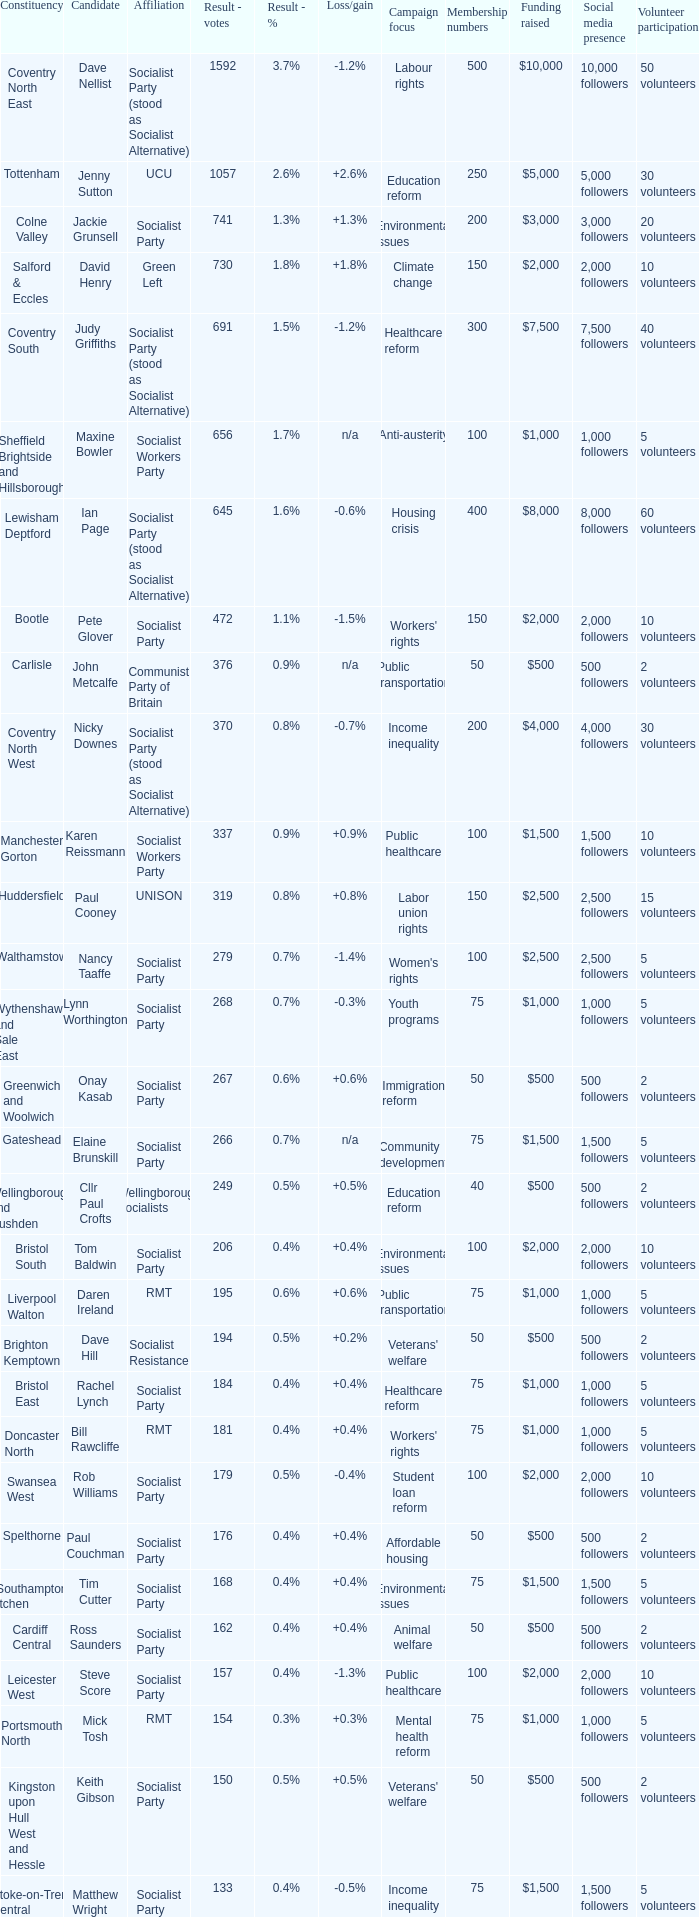What is every candidate for the Cardiff Central constituency? Ross Saunders. 